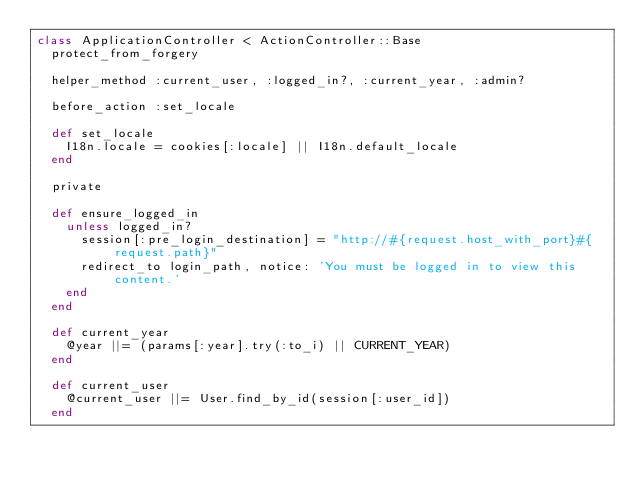Convert code to text. <code><loc_0><loc_0><loc_500><loc_500><_Ruby_>class ApplicationController < ActionController::Base
  protect_from_forgery

  helper_method :current_user, :logged_in?, :current_year, :admin?

  before_action :set_locale

  def set_locale
    I18n.locale = cookies[:locale] || I18n.default_locale
  end

  private

  def ensure_logged_in
    unless logged_in?
      session[:pre_login_destination] = "http://#{request.host_with_port}#{request.path}"
      redirect_to login_path, notice: 'You must be logged in to view this content.'
    end
  end

  def current_year
    @year ||= (params[:year].try(:to_i) || CURRENT_YEAR)
  end

  def current_user
    @current_user ||= User.find_by_id(session[:user_id])
  end
</code> 